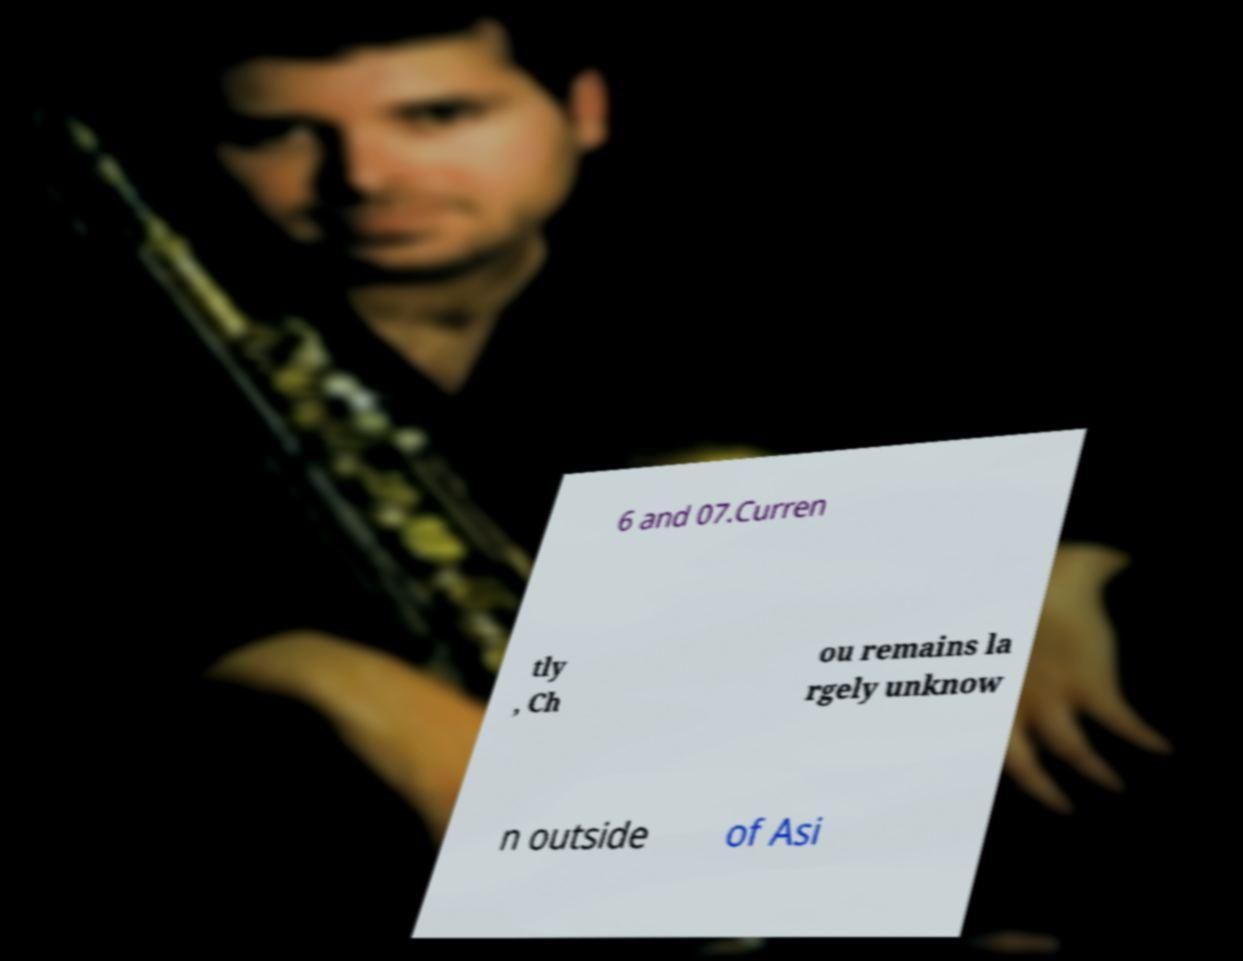There's text embedded in this image that I need extracted. Can you transcribe it verbatim? 6 and 07.Curren tly , Ch ou remains la rgely unknow n outside of Asi 